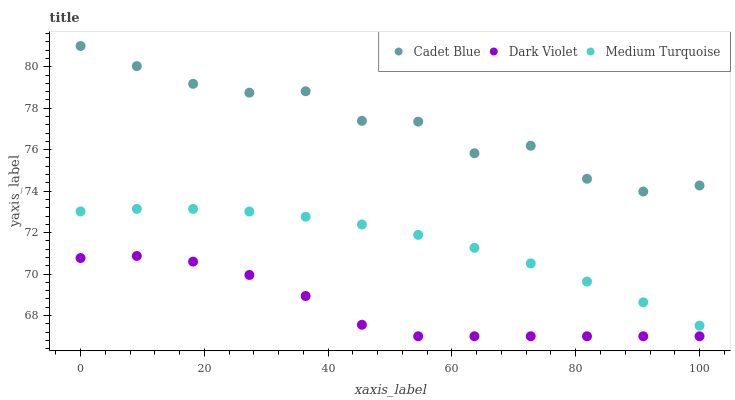Does Dark Violet have the minimum area under the curve?
Answer yes or no. Yes. Does Cadet Blue have the maximum area under the curve?
Answer yes or no. Yes. Does Medium Turquoise have the minimum area under the curve?
Answer yes or no. No. Does Medium Turquoise have the maximum area under the curve?
Answer yes or no. No. Is Medium Turquoise the smoothest?
Answer yes or no. Yes. Is Cadet Blue the roughest?
Answer yes or no. Yes. Is Dark Violet the smoothest?
Answer yes or no. No. Is Dark Violet the roughest?
Answer yes or no. No. Does Dark Violet have the lowest value?
Answer yes or no. Yes. Does Medium Turquoise have the lowest value?
Answer yes or no. No. Does Cadet Blue have the highest value?
Answer yes or no. Yes. Does Medium Turquoise have the highest value?
Answer yes or no. No. Is Medium Turquoise less than Cadet Blue?
Answer yes or no. Yes. Is Cadet Blue greater than Dark Violet?
Answer yes or no. Yes. Does Medium Turquoise intersect Cadet Blue?
Answer yes or no. No. 